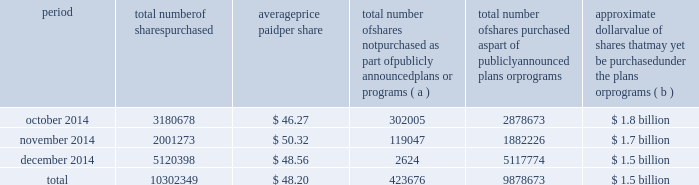The table discloses purchases of shares of valero 2019s common stock made by us or on our behalf during the fourth quarter of period total number of shares purchased average price paid per share total number of shares not purchased as part of publicly announced plans or programs ( a ) total number of shares purchased as part of publicly announced plans or programs approximate dollar value of shares that may yet be purchased under the plans or programs ( b ) .
( a ) the shares reported in this column represent purchases settled in the fourth quarter of 2014 relating to ( i ) our purchases of shares in open-market transactions to meet our obligations under stock-based compensation plans , and ( ii ) our purchases of shares from our employees and non-employee directors in connection with the exercise of stock options , the vesting of restricted stock , and other stock compensation transactions in accordance with the terms of our stock-based compensation plans .
( b ) on february 28 , 2008 , we announced that our board of directors approved a $ 3 billion common stock purchase program .
This $ 3 billion program has no expiration date. .
For the quarter ended december 2014 , what was the percent of the total number of shares purchased as part of publicly announced plans or programs in november? 
Computations: (1882226 / 9878673)
Answer: 0.19053. The table discloses purchases of shares of valero 2019s common stock made by us or on our behalf during the fourth quarter of period total number of shares purchased average price paid per share total number of shares not purchased as part of publicly announced plans or programs ( a ) total number of shares purchased as part of publicly announced plans or programs approximate dollar value of shares that may yet be purchased under the plans or programs ( b ) .
( a ) the shares reported in this column represent purchases settled in the fourth quarter of 2014 relating to ( i ) our purchases of shares in open-market transactions to meet our obligations under stock-based compensation plans , and ( ii ) our purchases of shares from our employees and non-employee directors in connection with the exercise of stock options , the vesting of restricted stock , and other stock compensation transactions in accordance with the terms of our stock-based compensation plans .
( b ) on february 28 , 2008 , we announced that our board of directors approved a $ 3 billion common stock purchase program .
This $ 3 billion program has no expiration date. .
What was the value of all the shares purchased in october? 
Computations: (3180678 * 46.27)
Answer: 147169971.06. 